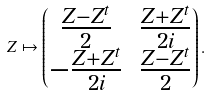<formula> <loc_0><loc_0><loc_500><loc_500>Z \mapsto \begin{pmatrix} \frac { Z - Z ^ { t } } { 2 } & \frac { Z + Z ^ { t } } { 2 i } \\ - \frac { Z + Z ^ { t } } { 2 i } & \frac { Z - Z ^ { t } } { 2 } \end{pmatrix} .</formula> 